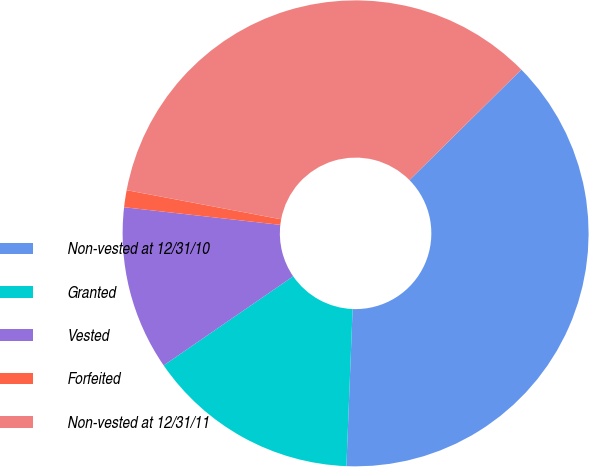Convert chart. <chart><loc_0><loc_0><loc_500><loc_500><pie_chart><fcel>Non-vested at 12/31/10<fcel>Granted<fcel>Vested<fcel>Forfeited<fcel>Non-vested at 12/31/11<nl><fcel>38.03%<fcel>14.78%<fcel>11.38%<fcel>1.18%<fcel>34.63%<nl></chart> 